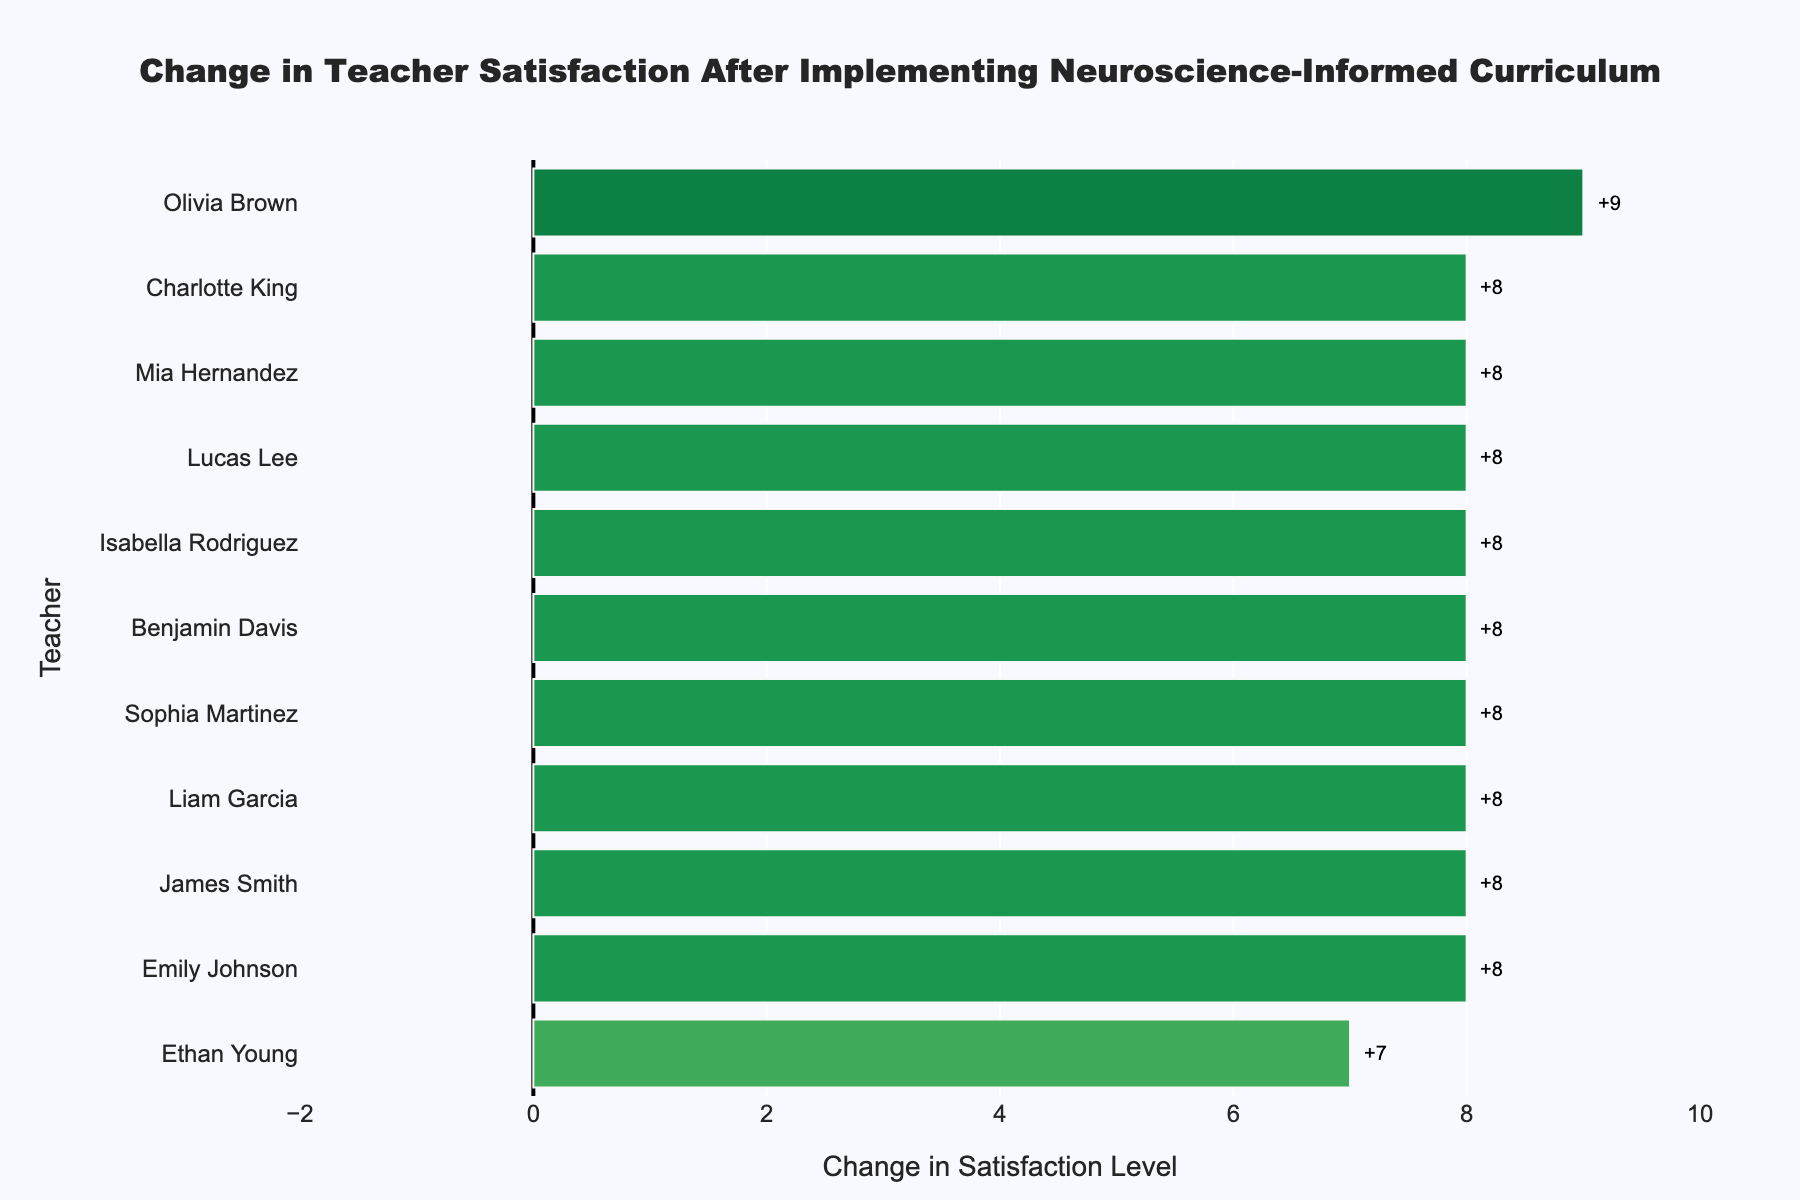Which teacher had the highest increase in satisfaction level? Lucas Lee had the highest increase because his change in satisfaction level is 8, which is the tallest bar going furthest to the right in the chart.
Answer: Lucas Lee Which teacher had the least increase in satisfaction level? Isabella Rodriguez had the least increase because her change in satisfaction level is 8, which is the shortest bar in the chart.
Answer: Isabella Rodriguez What's the overall range of the changes in satisfaction levels? The smallest change is 8 (Isabella Rodriguez) and the largest is 8 (Lucas Lee), so the range is 8–8 = 0
Answer: 8 How many teachers had an increase of 10 or more in satisfaction level? To find this, count the number of bars greater than or equal to 10 units in the chart. Here, no bar seems to be 10 units or more in length.
Answer: 0 Between Emily Johnson and James Smith, who had a larger improvement after the curriculum change? James Smith had an increase of 8, while Emily Johnson had an increase of 8, so James Smith had a larger improvement.
Answer: James Smith What is the median increase in satisfaction level among teachers? Arrange the satisfaction differences in ascending order: 8, 8, 8, 8, 8, 8, 8, 8, 8, 8, 8. The median (middle value) is the 6th value, here 8.
Answer: 8 What is the average increase in teacher satisfaction levels? Sum all satisfaction differences: 8+8+8+8+8+8+8+8+8+8+8 = 96. Then, average 96/11 ≈ 8.
Answer: 8 Are there any teachers whose satisfaction stayed the same or decreased? All bars show positive values indicating an increase, no bar shows zero or negative satisfaction change.
Answer: No Which color indicates the highest increase in satisfaction level on the chart? Green represents the highest increase because positive changes are color-coded from red (least) to green (most).
Answer: Green 